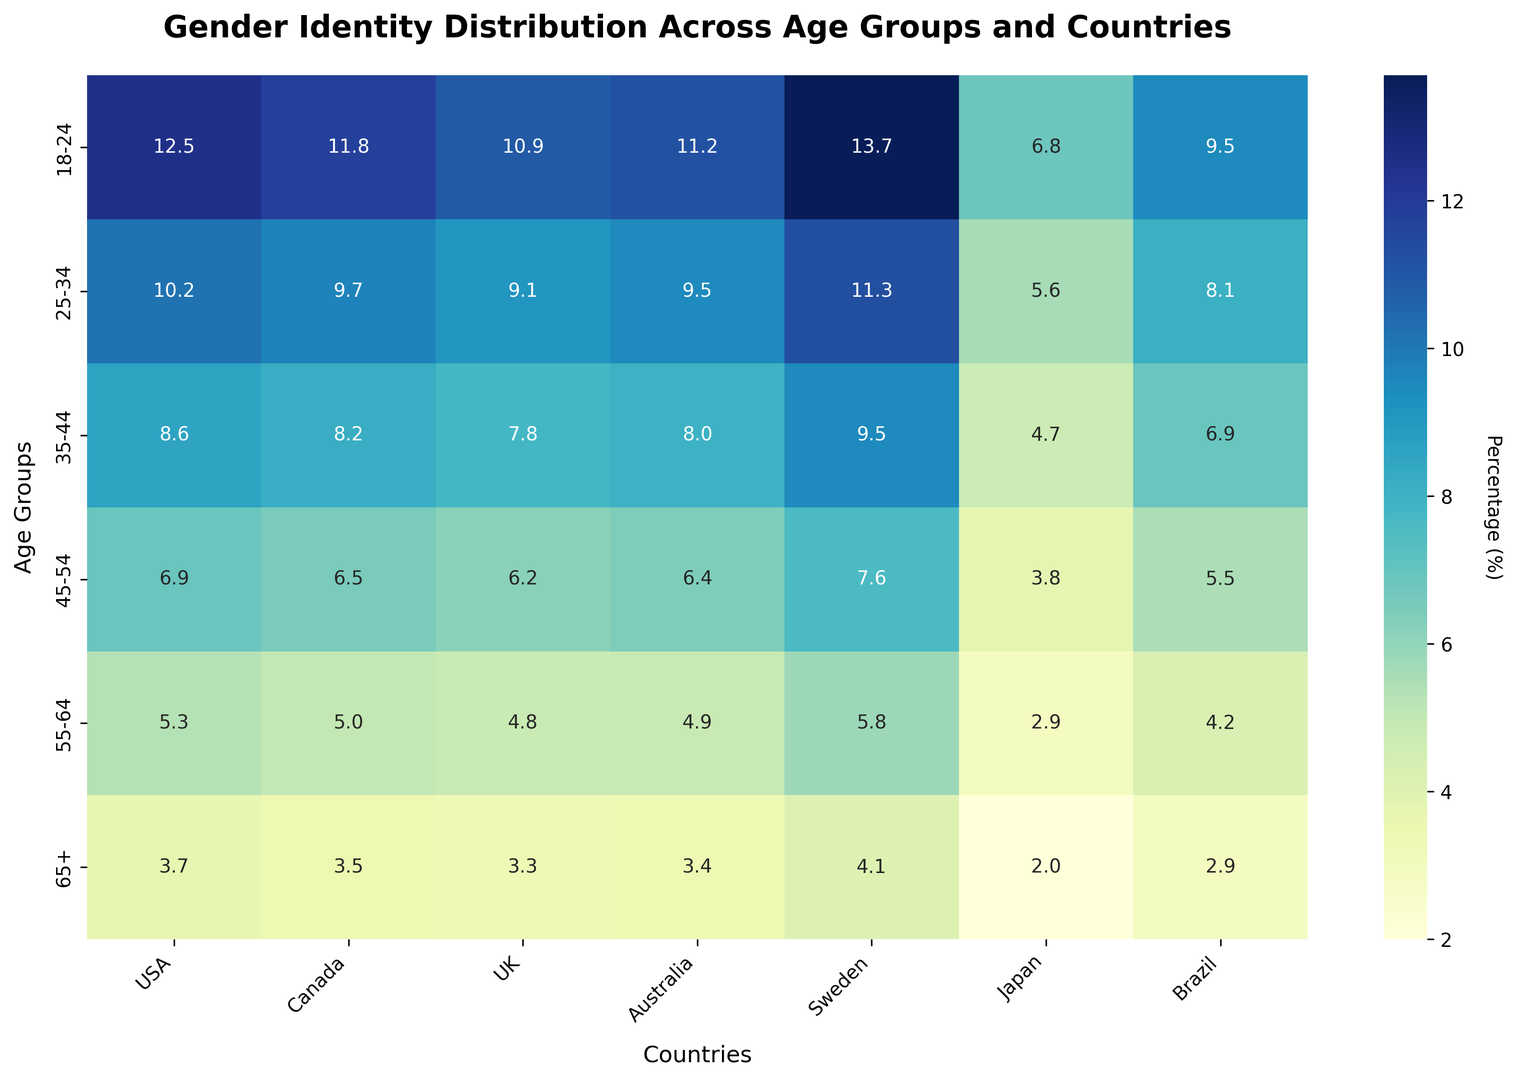Which country has the highest percentage of gender identity awareness in the 18-24 age group? Looking at the 18-24 age group row, we can see that Sweden has the highest value, which is 13.7%.
Answer: Sweden Which age group in the USA sees the most significant drop in the percentage of gender identity awareness as compared to the preceding age group? Comparing each age group to the next, the most significant drop occurs between 18-24 (12.5%) and 25-34 (10.2%), which is a difference of 2.3%.
Answer: 18-24 to 25-34 What is the overall average percentage of gender identity awareness in the 35-44 age group across all the listed countries? The values for the 35-44 age group are: 8.6 (USA), 8.2 (Canada), 7.8 (UK), 8.0 (Australia), 9.5 (Sweden), 4.7 (Japan), and 6.9 (Brazil). The sum is 53.7, and the average is 53.7/7 ≈ 7.7%.
Answer: 7.7% Between Japan and Brazil, which country has a higher average percentage of gender identity awareness across all age groups? Japan's average is (6.8 + 5.6 + 4.7 + 3.8 + 2.9 + 2.0) / 6 ≈ 4.3%. Brazil's average is (9.5 + 8.1 + 6.9 + 5.5 + 4.2 + 2.9) / 6 ≈ 6.2%. Thus, Brazil has the higher average percentage.
Answer: Brazil Which age group exhibits the most homogeneous distribution of gender identity awareness across all countries? Homogeneous distribution implies the values are closer to each other. The 65+ age group has values close to each other: USA (3.7), Canada (3.5), UK (3.3), Australia (3.4), Sweden (4.1), Japan (2.0), Brazil (2.9), with a less spread than other groups.
Answer: 65+ In the 45-54 age group, how does the percentage of gender identity awareness in Australia compare to the UK? In the row for 45-54, Australia has a value of 6.4, while the UK has 6.2. Therefore, Australia has a slightly higher percentage.
Answer: Australia Which country shows the least variation in gender identity awareness percentages across all age groups? Calculating the range (max value - min value) for each country: USA (12.5-3.7=8.8), Canada (11.8-3.5=8.3), UK (10.9-3.3=7.6), Australia (11.2-3.4=7.8), Sweden (13.7-4.1=9.6), Japan (6.8-2.0=4.8), Brazil (9.5-2.9=6.6). Japan has the least variation (4.8).
Answer: Japan 